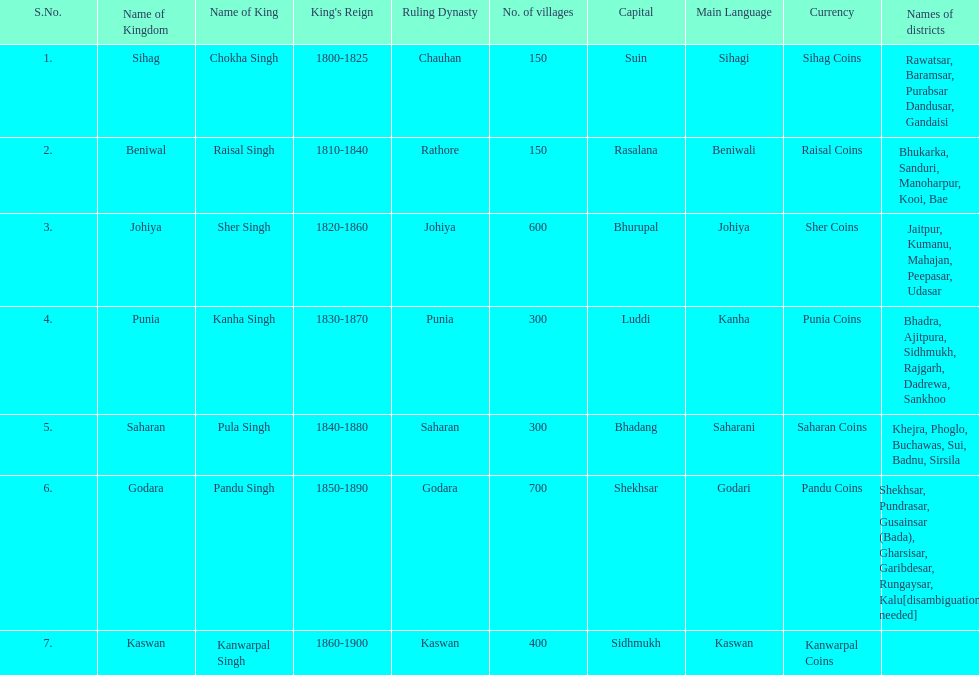Which kingdom has the most villages? Godara. 